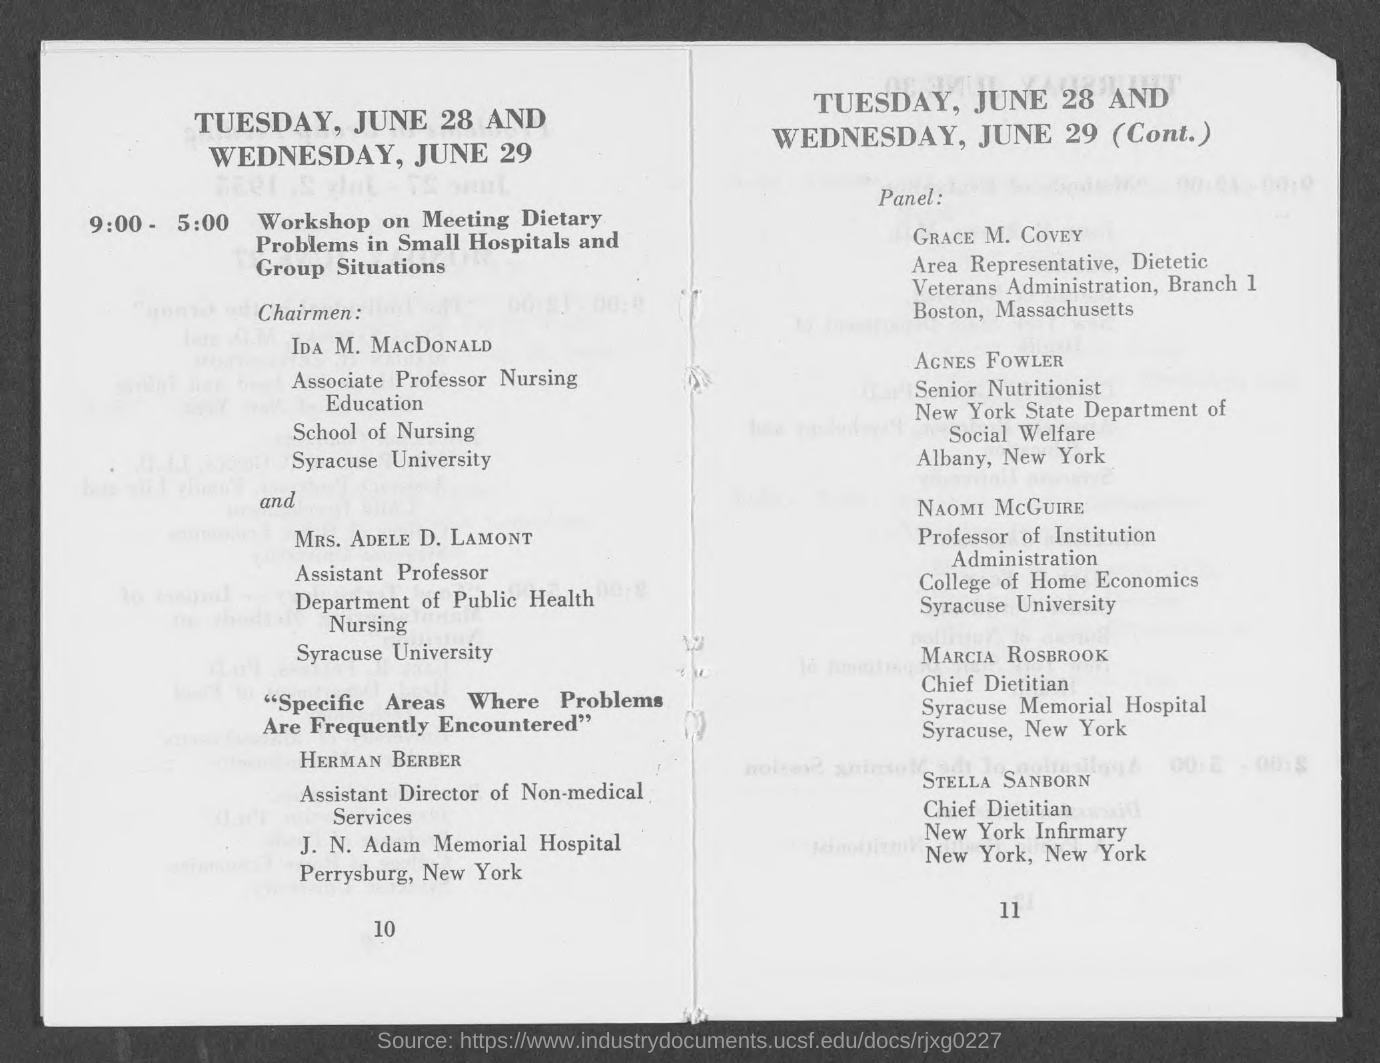Indicate a few pertinent items in this graphic. Herman Berber is the Assistant Director of Non-Medical Services at J.N Adam Memorial Hospital in Perrysburg. The individual known as "Chief Dietitian" at the New York Infirmary is named Stella Sanborn. The Senior Nutritionist of the New York State Department of Social Welfare is named Agnes Fowler. The workshop, conducted on June 28 at 9 am, focused on addressing dietary challenges faced by small hospitals and group settings. The 'Workshop on meeting dietary problems in small hospitals and group situations' will begin at 9:00. 